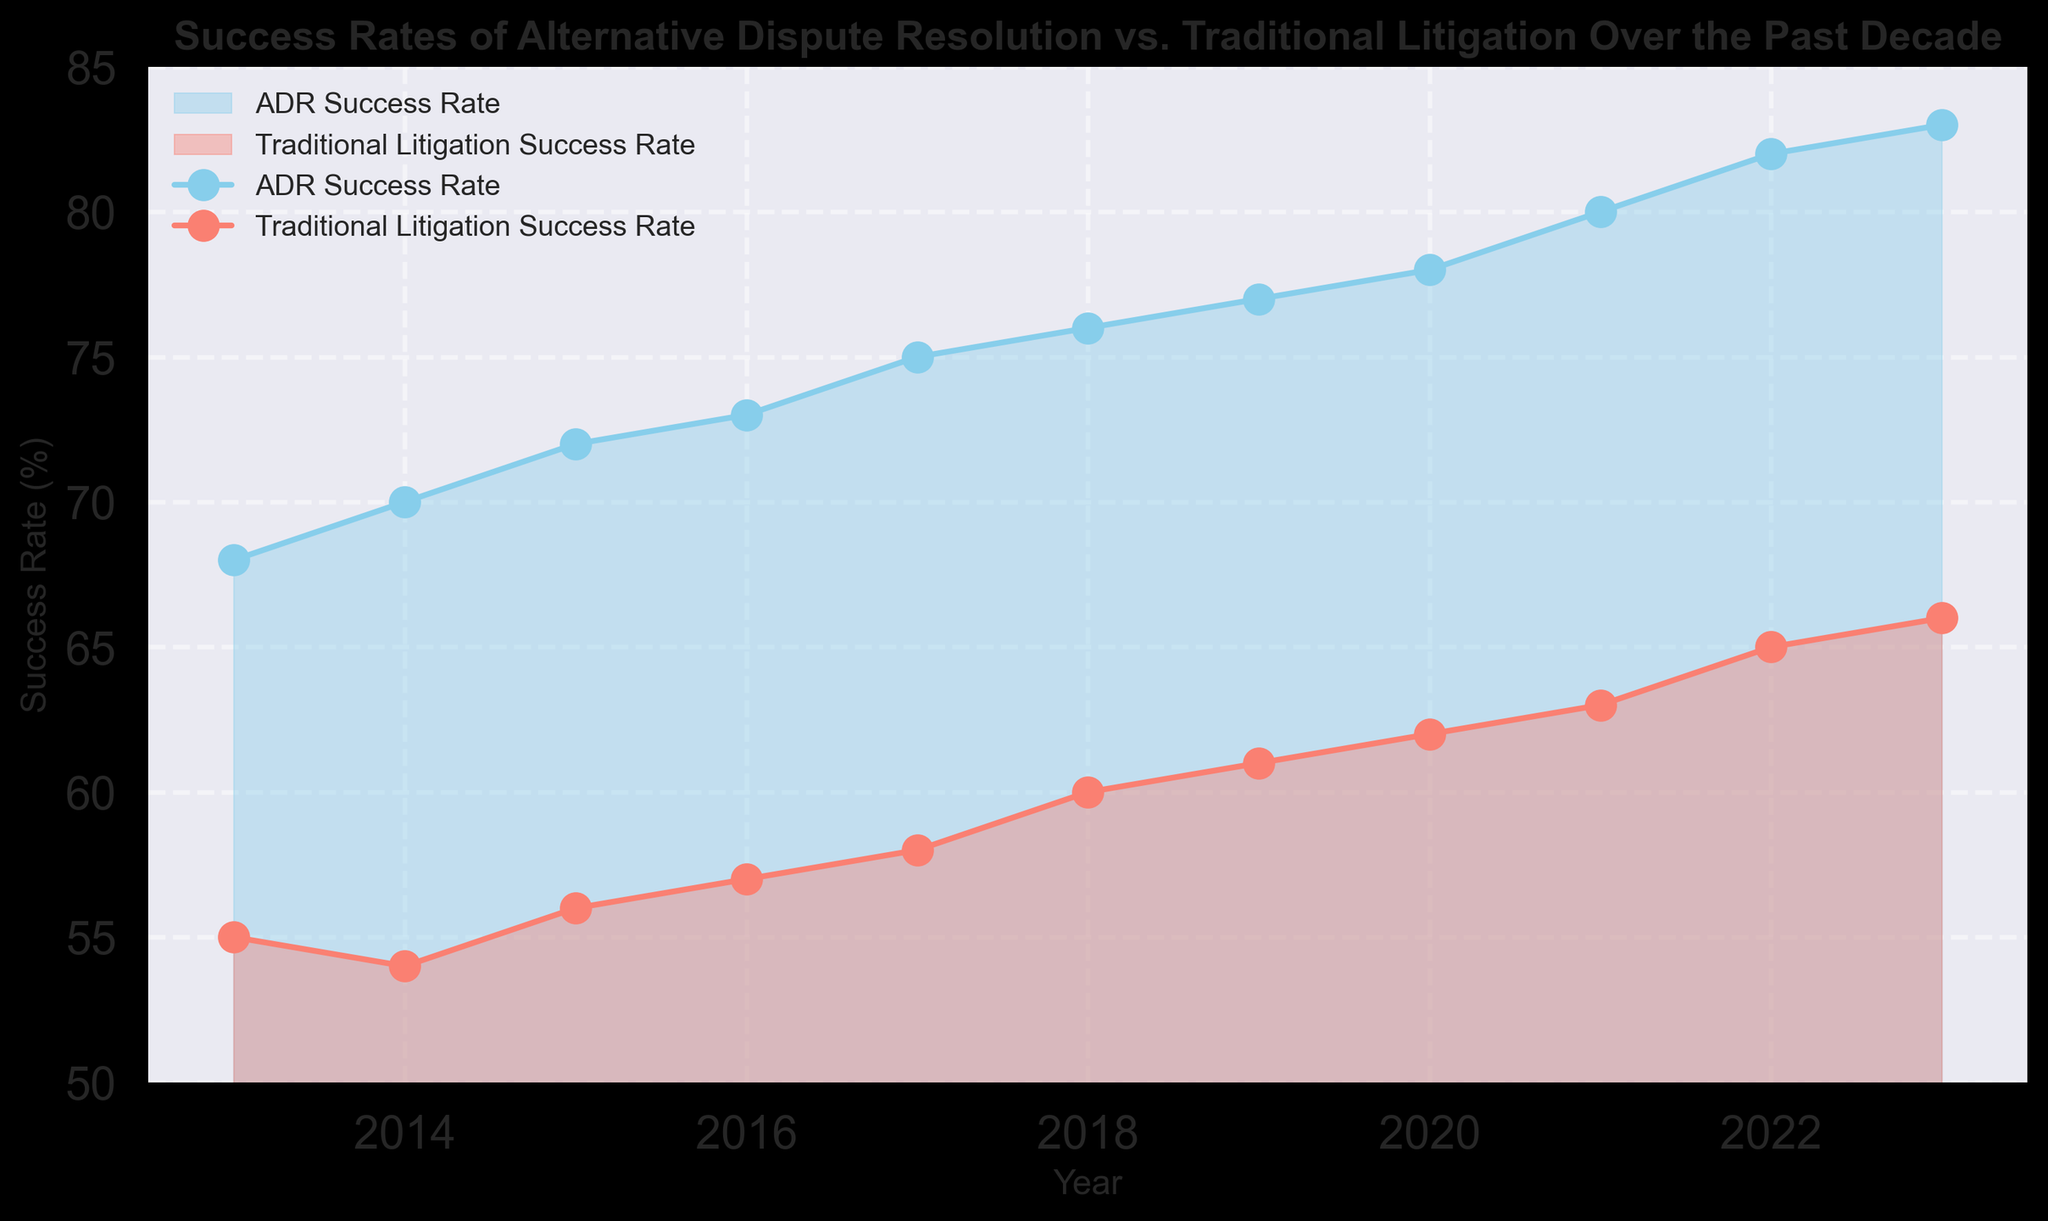What's the difference between the ADR and Traditional Litigation success rates in 2023? The ADR success rate in 2023 is 83%, and the Traditional Litigation success rate is 66%. The difference is 83% - 66% = 17%.
Answer: 17% How has the ADR success rate changed from 2013 to 2023? The ADR success rate in 2013 was 68%, and in 2023 it is 83%. The change is 83% - 68% = 15%.
Answer: 15% In which year(s) is the success rate of Traditional Litigation at least 60%? The Traditional Litigation success rate reaches 60% and above from the year 2018 onwards.
Answer: 2018-2023 Which year has the highest ADR success rate? Observing the area chart, the highest ADR success rate is in the most recent year, 2023, at 83%.
Answer: 2023 What is the average ADR success rate over the entire period? Calculating the average of the ADR success rates from 2013 to 2023: (68+70+72+73+75+76+77+78+80+82+83)/11 = 75.27%.
Answer: 75.27% What is the trend of Traditional Litigation success rate from 2013 to 2023? The Traditional Litigation success rate shows a consistent upward trend from 55% in 2013 to 66% in 2023.
Answer: Upward Trend How many years did the ADR success rate increase consecutively? The ADR success rate increased every year from 2013 to 2023. This is a streak of 10 consecutive years.
Answer: 10 years Which rate has a steeper increase over the decade, ADR or Traditional Litigation? From the data, ADR increased from 68% to 83% (15% increase) and Traditional Litigation from 55% to 66% (11% increase). ADR has the steeper increase.
Answer: ADR In which year is the gap between ADR and Traditional Litigation success rates the smallest? The smallest gap is observed in 2013, where the difference is 68% - 55% = 13%.
Answer: 2013 